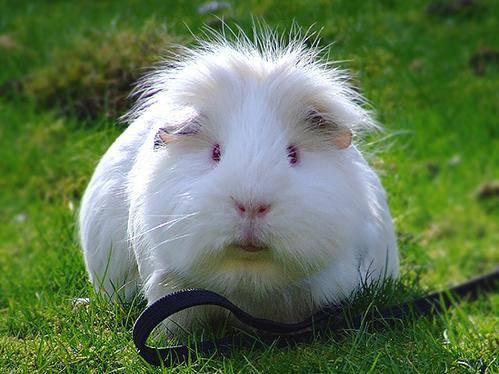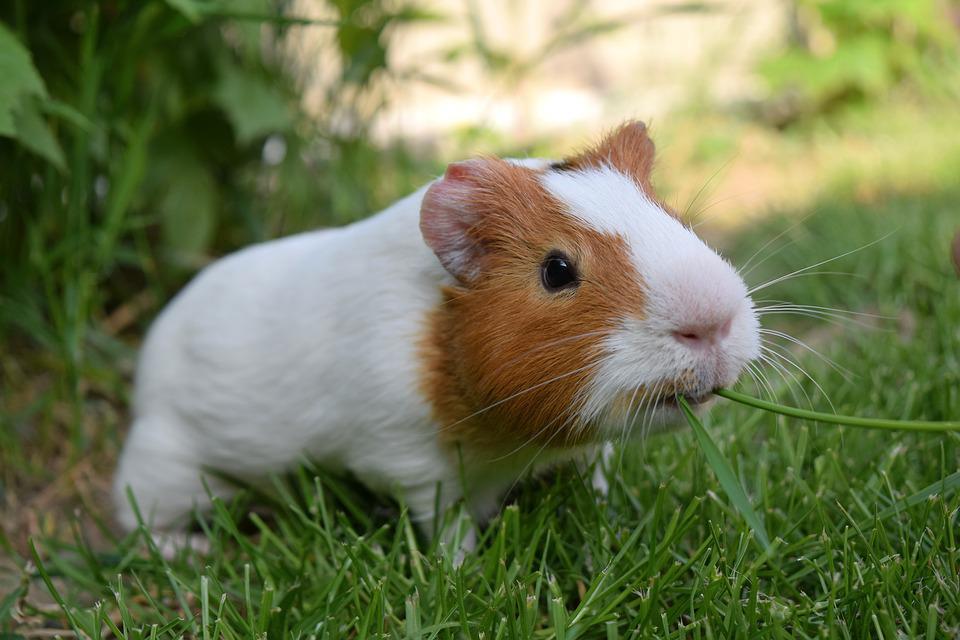The first image is the image on the left, the second image is the image on the right. Evaluate the accuracy of this statement regarding the images: "the image on the right contains a flower". Is it true? Answer yes or no. No. 